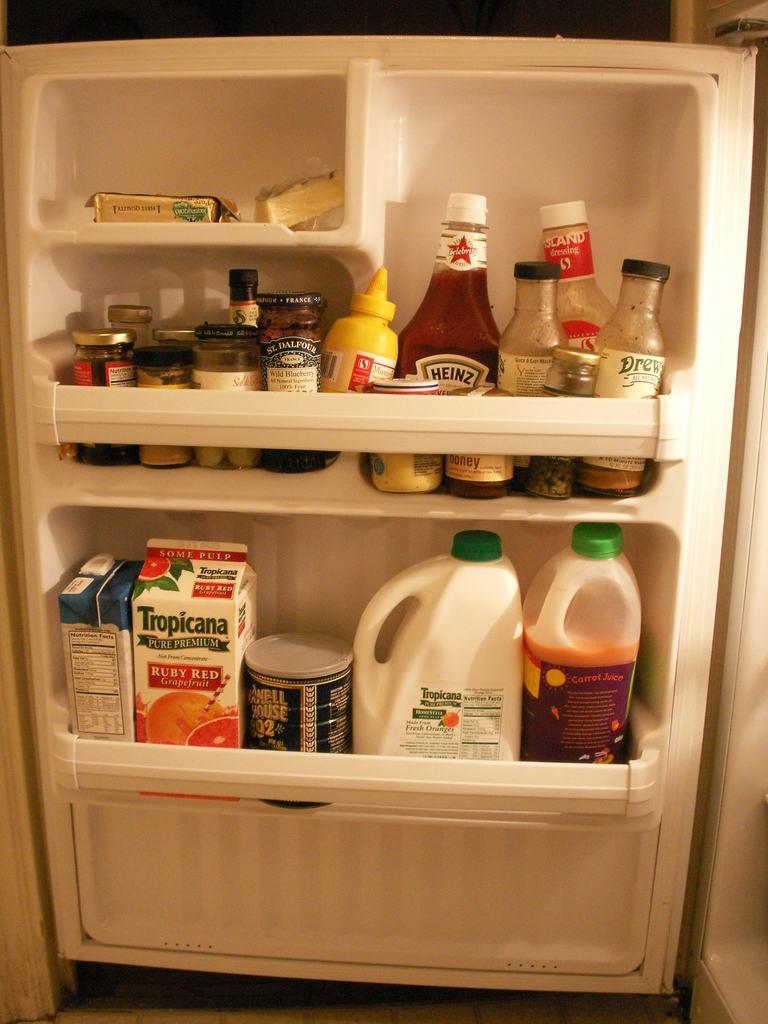<image>
Offer a succinct explanation of the picture presented. An open refridgerator containing different things including Tropicana. 